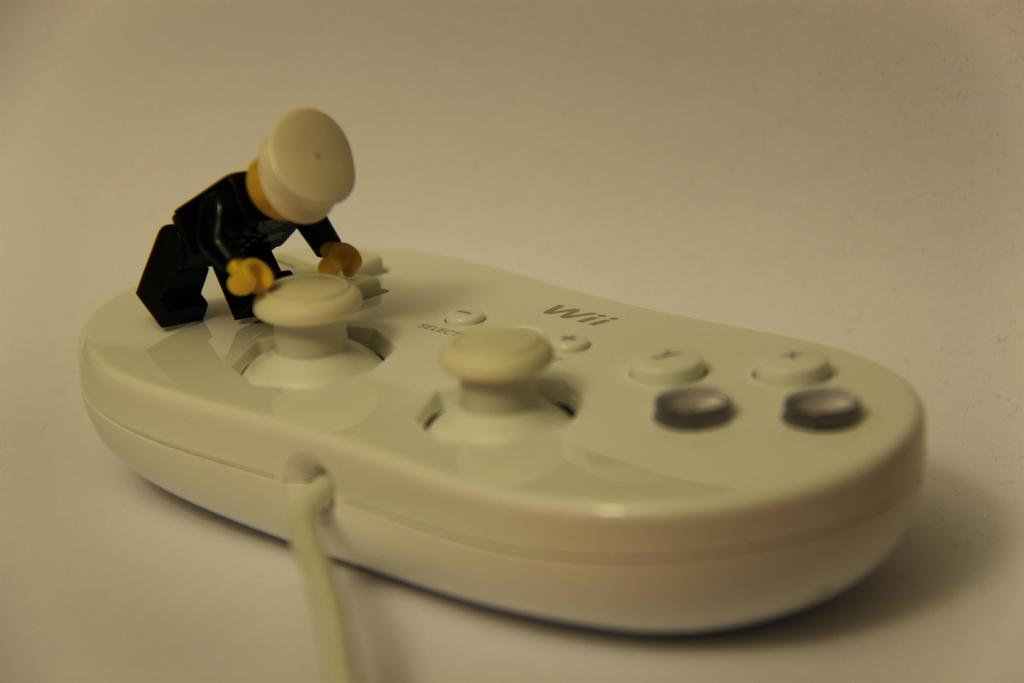What is the main object in the image? There is a joystick in the image. Is there anything connected to the joystick? Yes, there is a toy attached to the joystick. What type of pear is being used by the committee in the image? There is no pear or committee present in the image; it only features a joystick with a toy attached to it. 